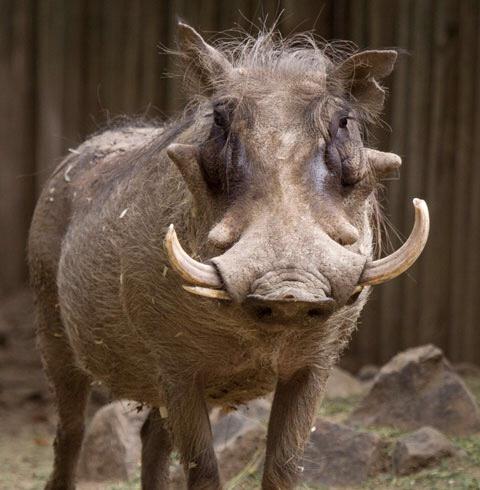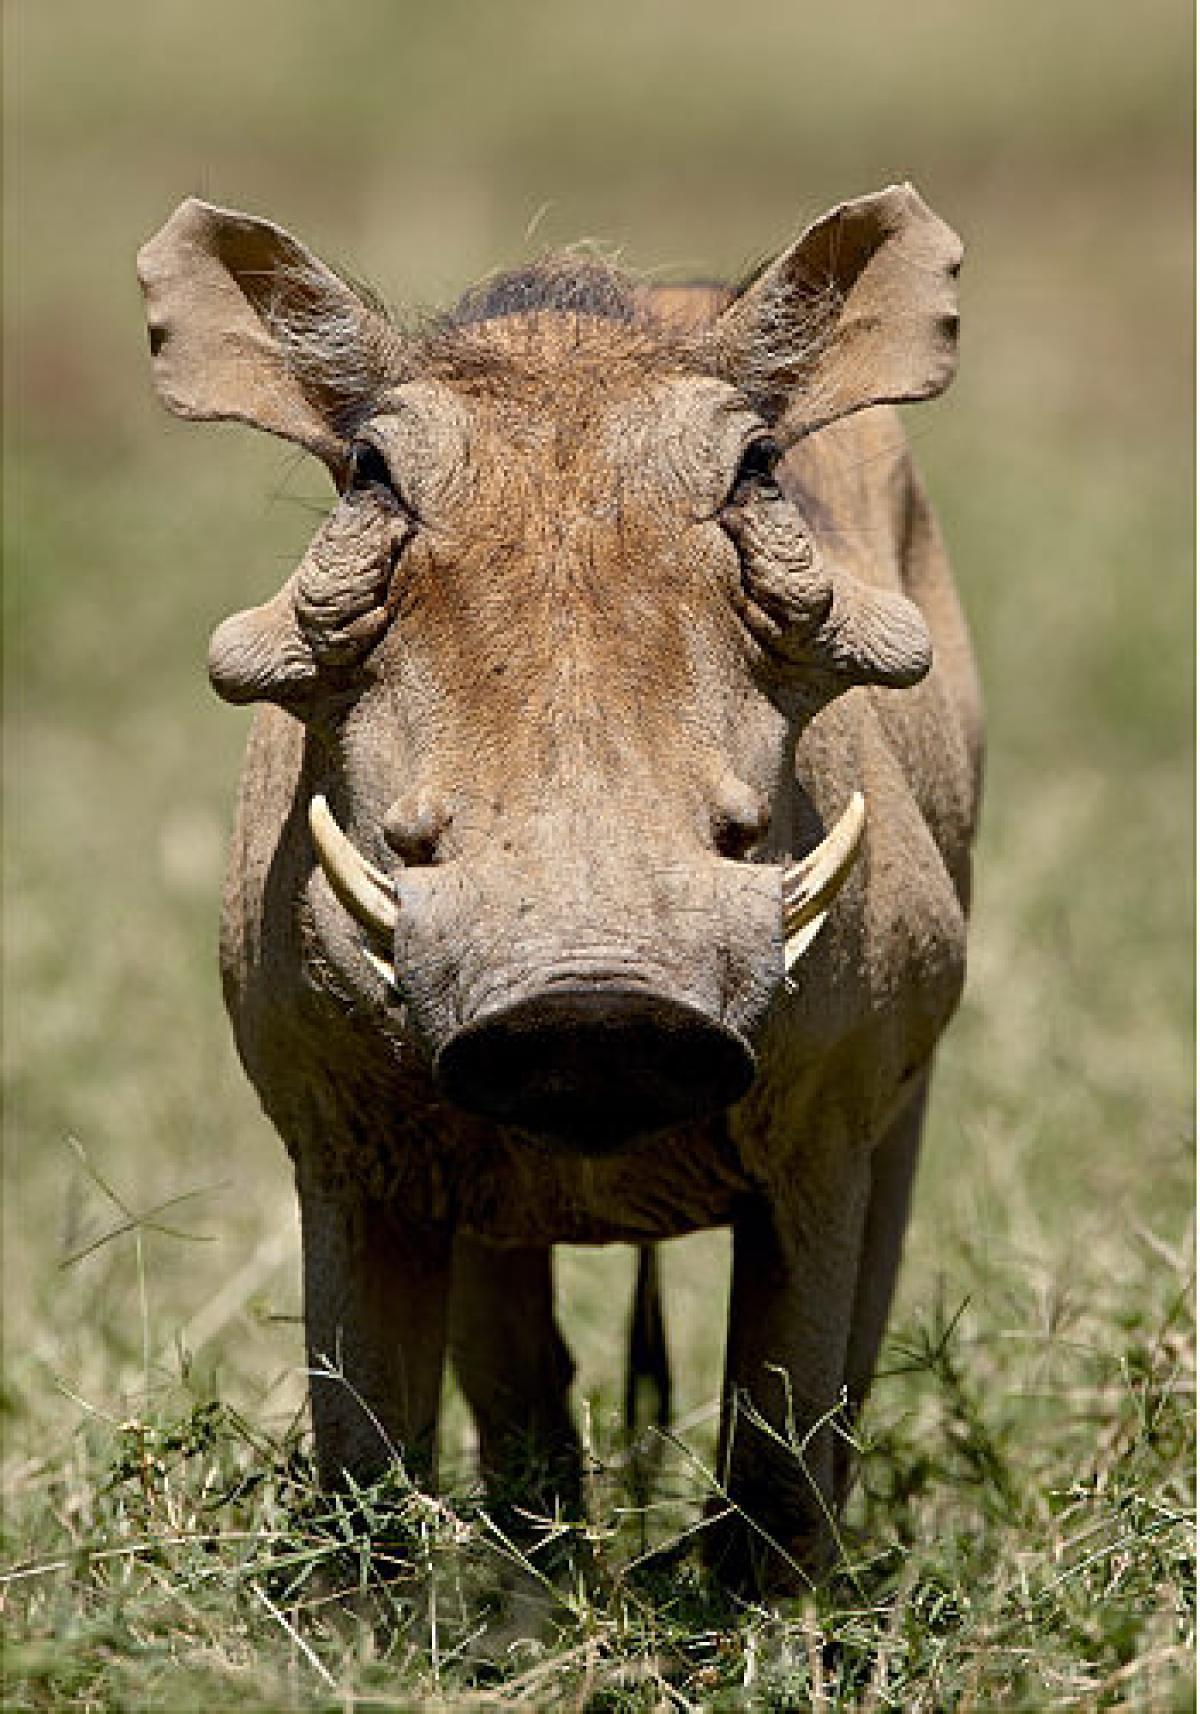The first image is the image on the left, the second image is the image on the right. For the images shown, is this caption "There are two hogs in total." true? Answer yes or no. Yes. The first image is the image on the left, the second image is the image on the right. For the images displayed, is the sentence "Each image includes a warthog with its head facing the camera." factually correct? Answer yes or no. Yes. 